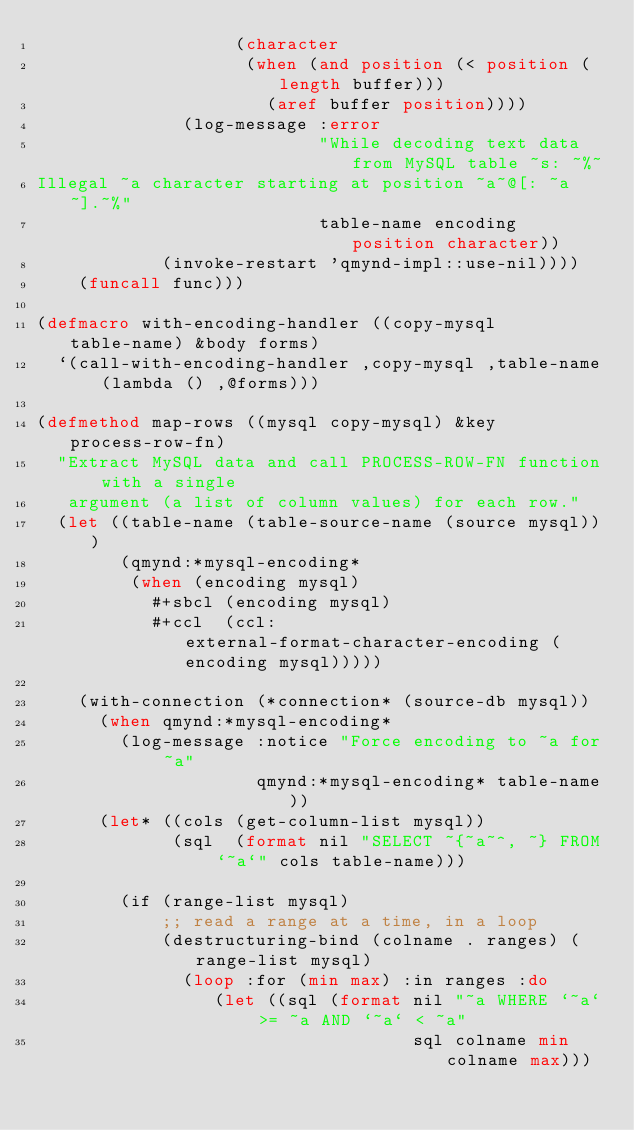<code> <loc_0><loc_0><loc_500><loc_500><_Lisp_>                   (character
                    (when (and position (< position (length buffer)))
                      (aref buffer position))))
              (log-message :error
                           "While decoding text data from MySQL table ~s: ~%~
Illegal ~a character starting at position ~a~@[: ~a~].~%"
                           table-name encoding position character))
            (invoke-restart 'qmynd-impl::use-nil))))
    (funcall func)))

(defmacro with-encoding-handler ((copy-mysql table-name) &body forms)
  `(call-with-encoding-handler ,copy-mysql ,table-name (lambda () ,@forms)))

(defmethod map-rows ((mysql copy-mysql) &key process-row-fn)
  "Extract MySQL data and call PROCESS-ROW-FN function with a single
   argument (a list of column values) for each row."
  (let ((table-name (table-source-name (source mysql)))
        (qmynd:*mysql-encoding*
         (when (encoding mysql)
           #+sbcl (encoding mysql)
           #+ccl  (ccl:external-format-character-encoding (encoding mysql)))))

    (with-connection (*connection* (source-db mysql))
      (when qmynd:*mysql-encoding*
        (log-message :notice "Force encoding to ~a for ~a"
                     qmynd:*mysql-encoding* table-name))
      (let* ((cols (get-column-list mysql))
             (sql  (format nil "SELECT ~{~a~^, ~} FROM `~a`" cols table-name)))

        (if (range-list mysql)
            ;; read a range at a time, in a loop
            (destructuring-bind (colname . ranges) (range-list mysql)
              (loop :for (min max) :in ranges :do
                 (let ((sql (format nil "~a WHERE `~a` >= ~a AND `~a` < ~a"
                                    sql colname min colname max)))</code> 